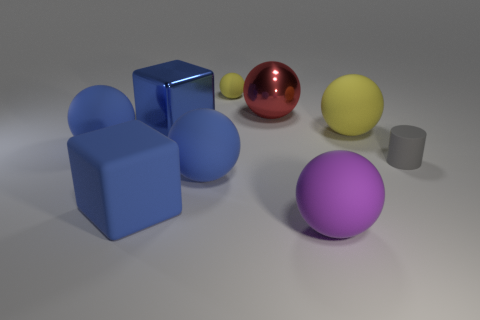What number of rubber cylinders have the same color as the big metal sphere?
Your answer should be compact. 0. Is there a object in front of the yellow object that is in front of the small yellow rubber thing?
Provide a short and direct response. Yes. Do the cube on the left side of the large blue shiny thing and the tiny thing on the left side of the gray object have the same color?
Your response must be concise. No. What color is the matte cube that is the same size as the blue shiny thing?
Your answer should be compact. Blue. Are there the same number of big purple spheres that are behind the gray rubber object and metallic cubes on the right side of the big metallic sphere?
Offer a terse response. Yes. The blue ball behind the tiny object in front of the big red metallic ball is made of what material?
Offer a terse response. Rubber. What number of objects are either gray matte things or large red spheres?
Provide a succinct answer. 2. What is the size of the other sphere that is the same color as the small ball?
Keep it short and to the point. Large. Are there fewer red shiny balls than red cylinders?
Provide a short and direct response. No. What size is the block that is the same material as the large red ball?
Offer a very short reply. Large. 